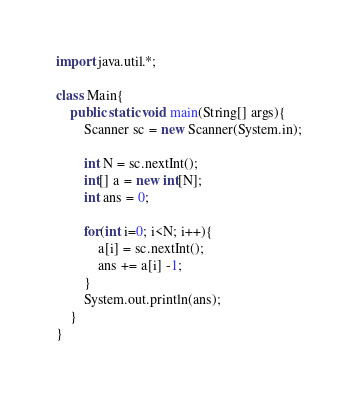Convert code to text. <code><loc_0><loc_0><loc_500><loc_500><_Java_>import java.util.*;

class Main{
    public static void main(String[] args){
        Scanner sc = new Scanner(System.in);

        int N = sc.nextInt();
        int[] a = new int[N];
        int ans = 0;

        for(int i=0; i<N; i++){
            a[i] = sc.nextInt();
            ans += a[i] -1;
        }
        System.out.println(ans);
    }
}</code> 